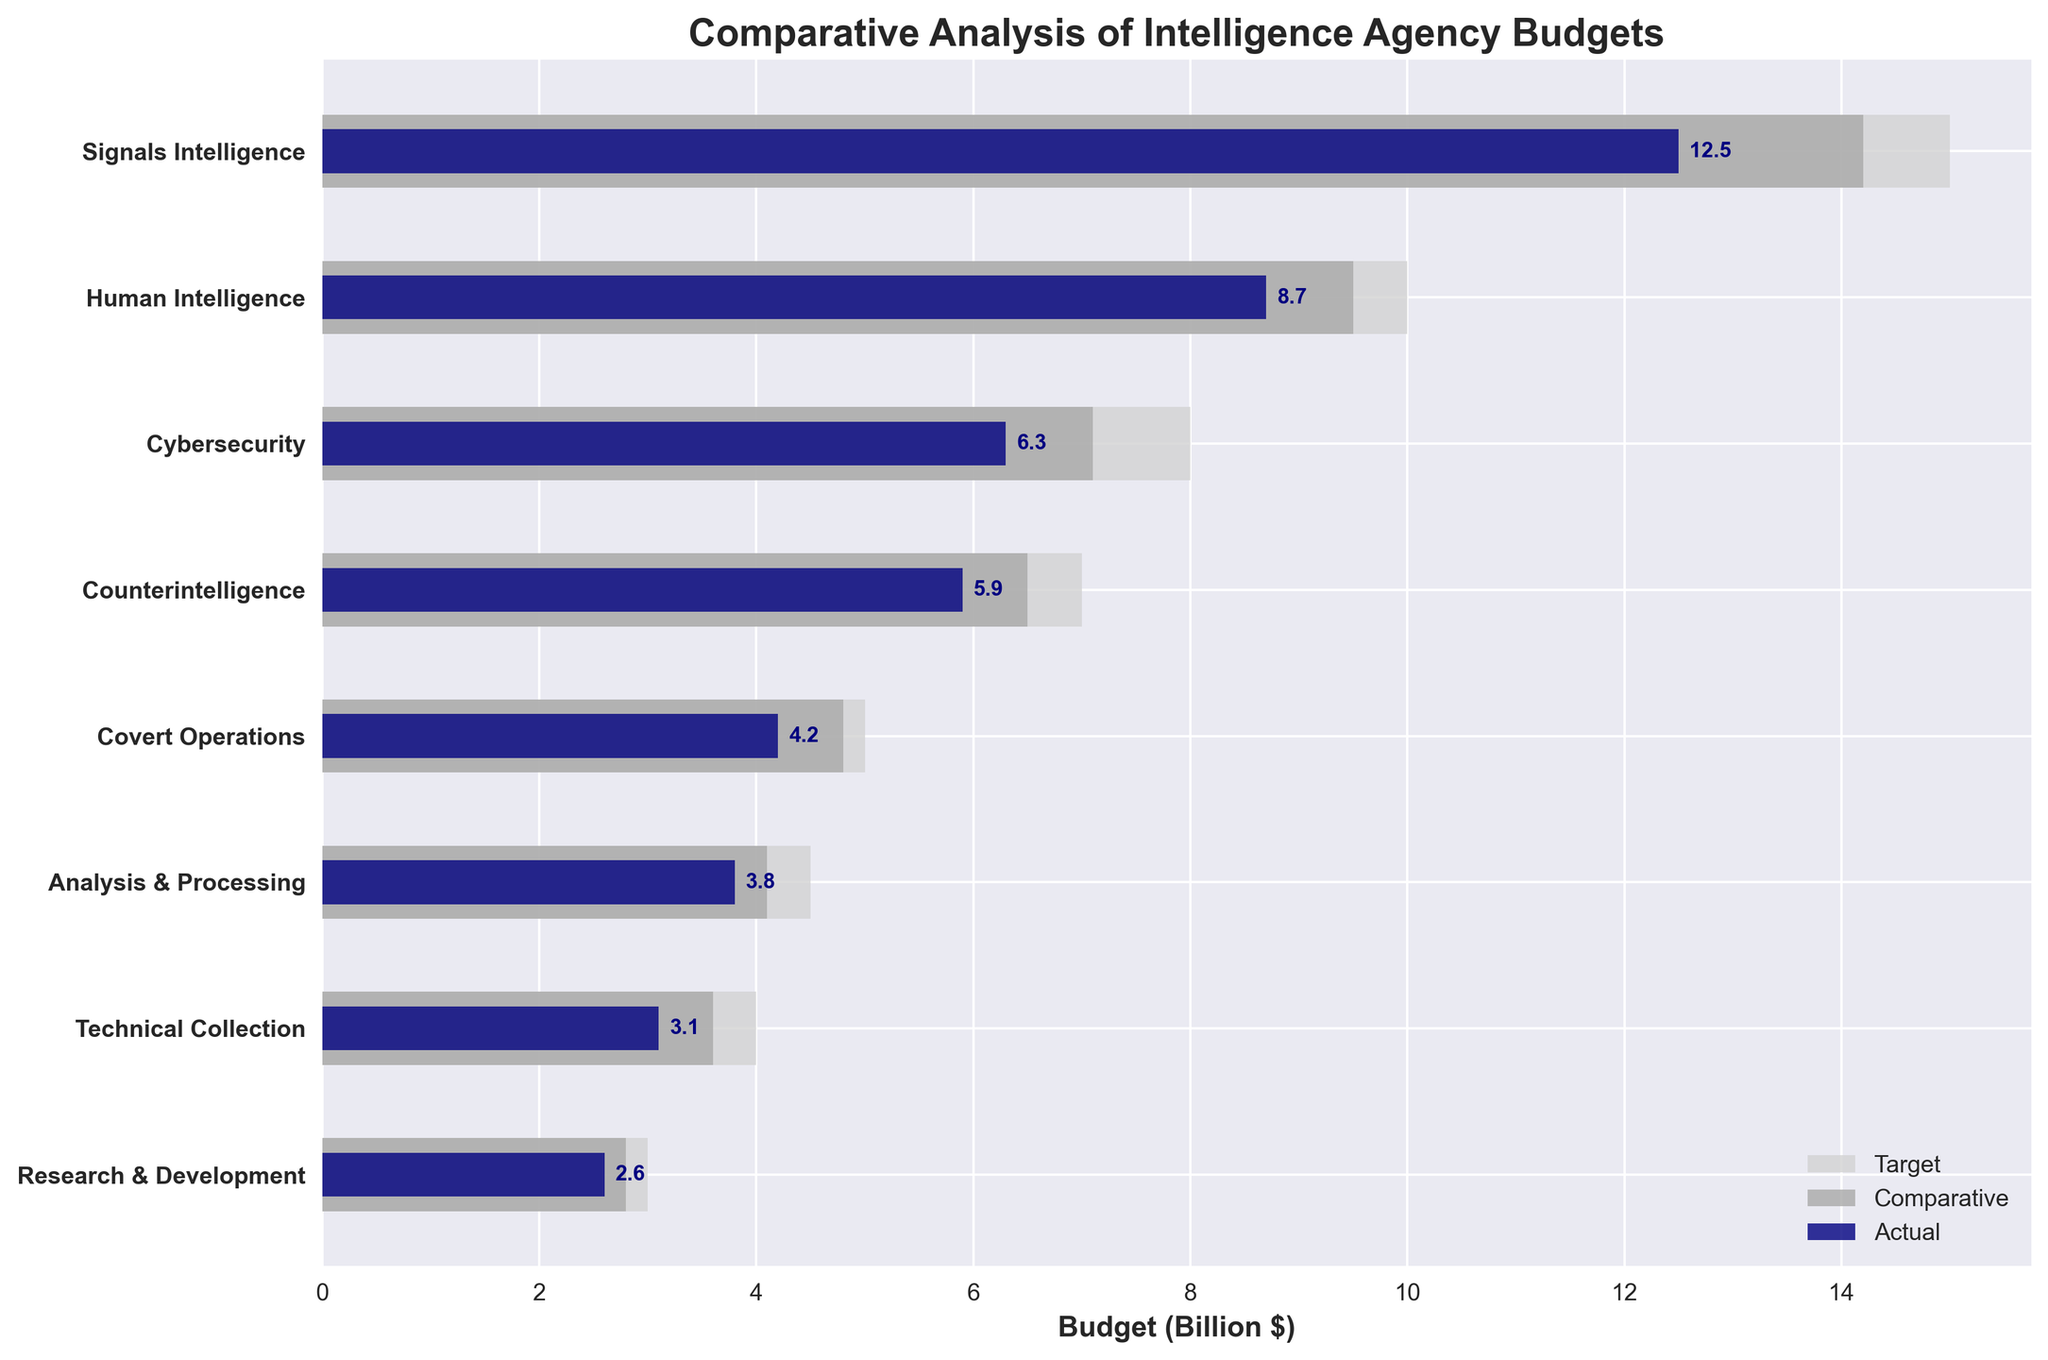How many operational areas are shown in the bullet chart? The y-axis lists the categories, which represent different operational areas. By counting the categories, we see there are 8 areas shown in the chart.
Answer: 8 What is the title of the bullet chart? The title is usually placed at the top of the figure. In this case, it reads: "Comparative Analysis of Intelligence Agency Budgets".
Answer: Comparative Analysis of Intelligence Agency Budgets Which operational area has the highest actual budget? The actual budget is represented by the navy-colored bars. By comparing the lengths, we see "Signals Intelligence" has the highest actual budget of 12.5 billion dollars.
Answer: Signals Intelligence What is the difference between the target and actual budget for Cybersecurity? The target budget in Cybersecurity is 8 billion dollars, and the actual budget is 6.3 billion dollars. The difference is calculated as 8 - 6.3.
Answer: 1.7 billion dollars Is the actual budget for Human Intelligence greater than the comparative budget for Human Intelligence? For Human Intelligence, the actual budget is represented by the navy-colored bar at 8.7 billion dollars, and the comparative budget by the dark grey bar at 9.5 billion dollars. Since 8.7 is less than 9.5, the actual budget is not greater.
Answer: No Which operational area meets its target budget most closely? Meeting the target budget most closely means having the smallest difference between the actual and target budget. By examining the differences for each category, "Analysis & Processing" has the actual value of 3.8 billion dollars against a target of 4.5 billion dollars, which is 0.7 billion dollars difference. This is the smallest difference among all categories.
Answer: Analysis & Processing What is the sum of the target budgets for Signals Intelligence and Covert Operations? The target budget for Signals Intelligence is 15 billion dollars and for Covert Operations is 5 billion dollars. Summing these gives 15 + 5.
Answer: 20 billion dollars Between Technical Collection and Research & Development, which area has a larger comparative budget? The comparative budgets are represented by the dark grey bars. For Technical Collection, the comparative budget is 3.6 billion dollars, and for Research & Development, it is 2.8 billion dollars. Comparing these two values, Technical Collection has a larger comparative budget.
Answer: Technical Collection 